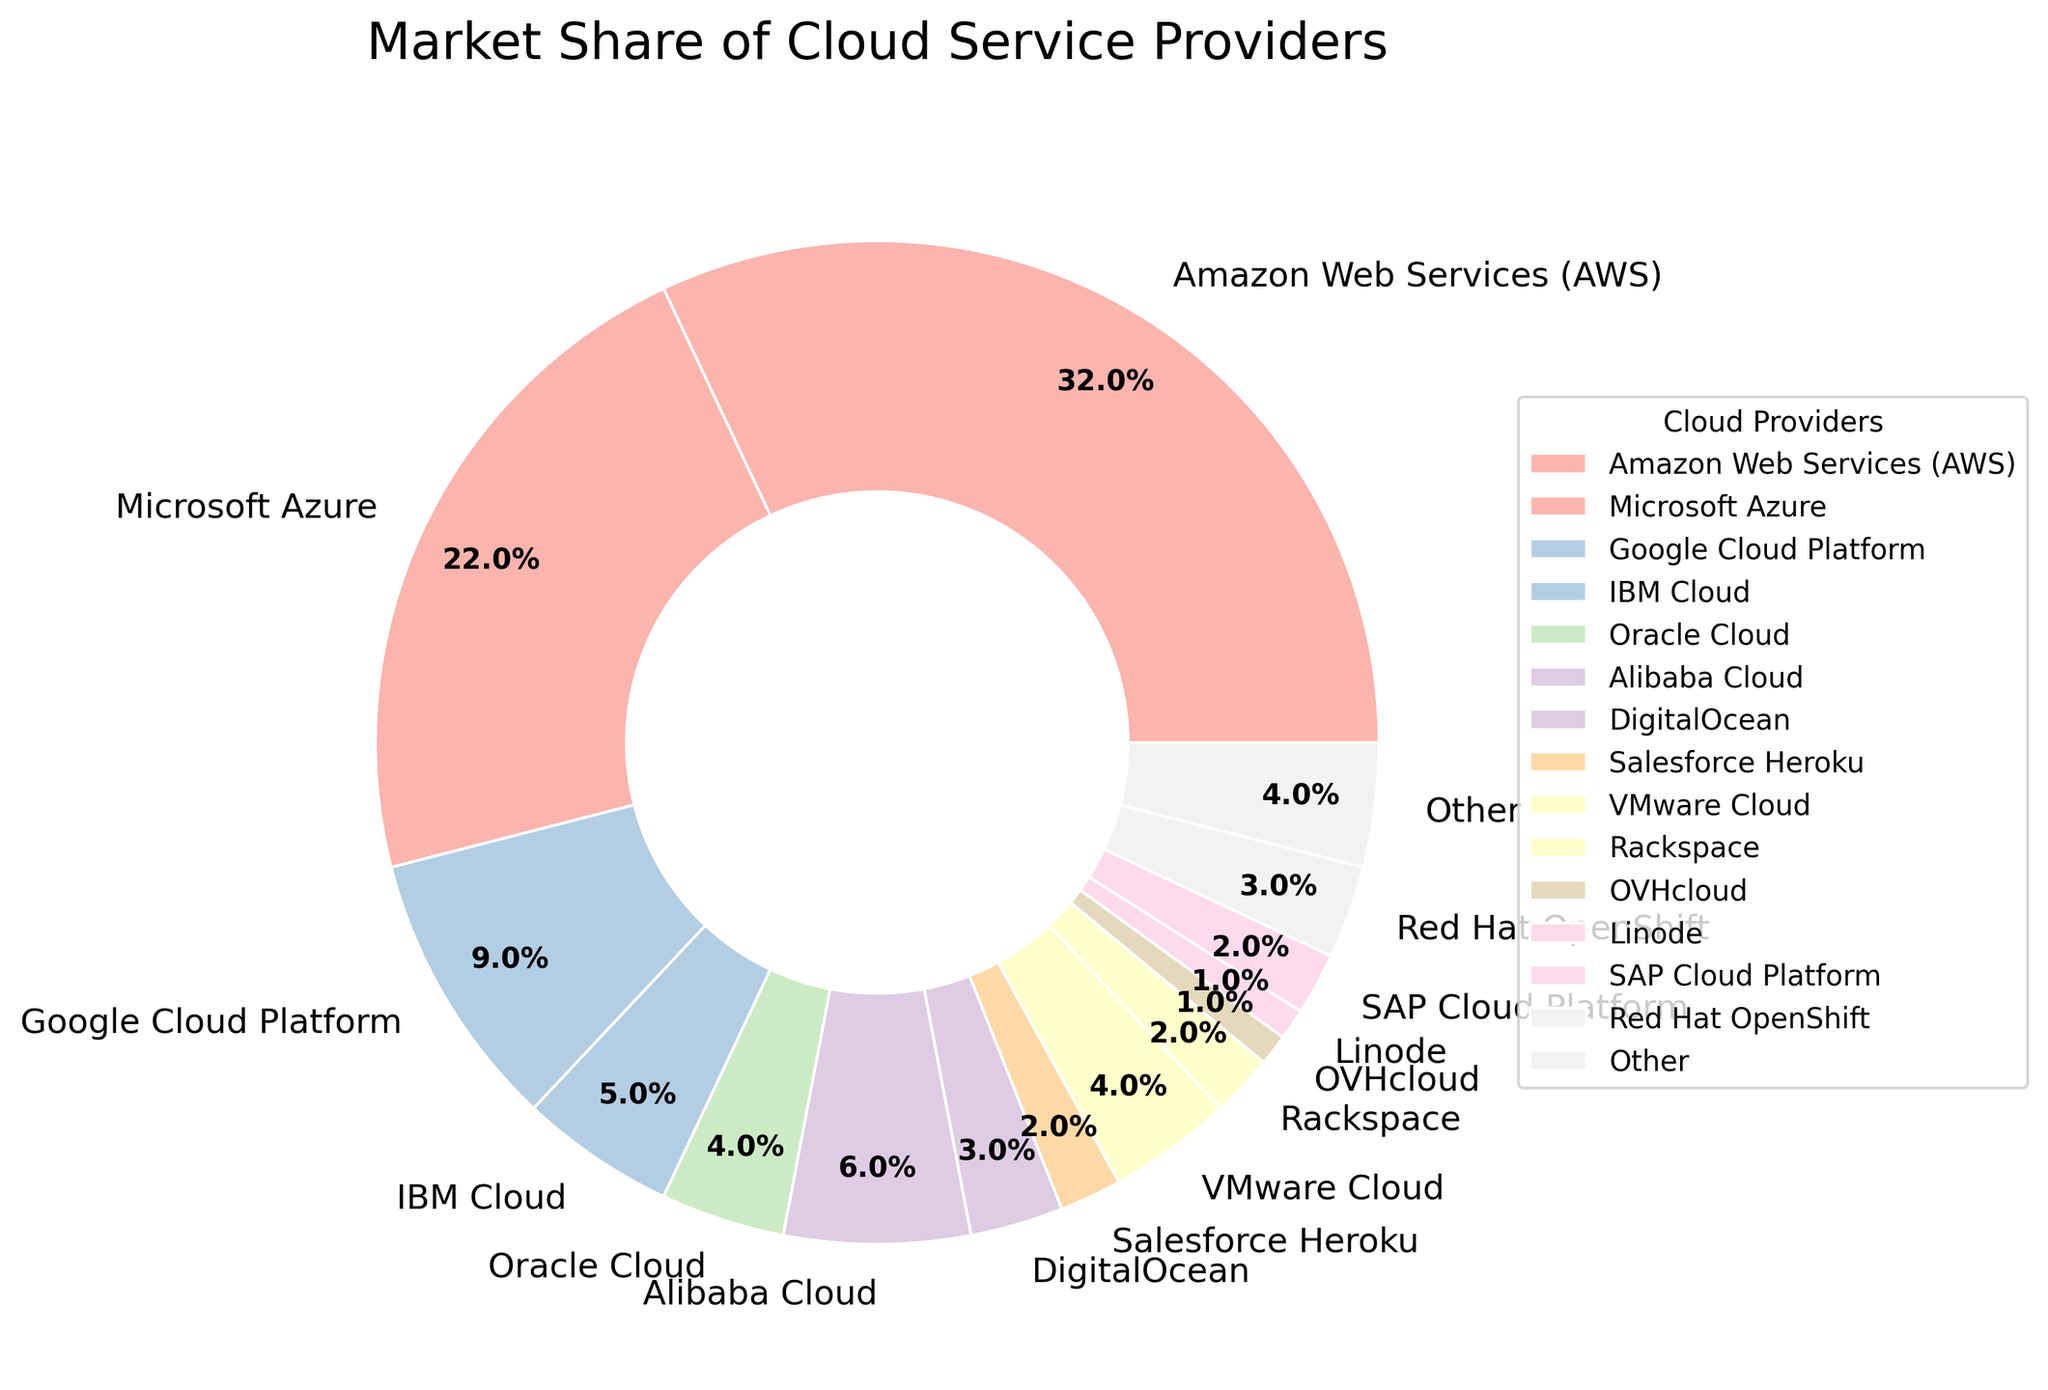What is the market share of Amazon Web Services (AWS)? AWS has a label indicating its market share. The label on the segment reads 32%.
Answer: 32% Which cloud provider holds the second-largest market share? By examining the segments, the second-largest share corresponds to Microsoft Azure, which is labeled as 22%.
Answer: Microsoft Azure What is the combined market share of IBM Cloud, Oracle Cloud, and VMware Cloud? Sum the market shares of IBM Cloud (5%), Oracle Cloud (4%), and VMware Cloud (4%): 5% + 4% + 4% = 13%.
Answer: 13% Is the market share of Alibaba Cloud greater than that of Google Cloud Platform? Alibaba Cloud's market share is 6%, while Google Cloud Platform's market share is 9%. Comparing these, 6% < 9%.
Answer: No What is the total market share of cloud providers with a market share of 2% each? Identify providers with 2% each: Salesforce Heroku, Rackspace, SAP Cloud Platform. Sum these shares: 2% + 2% + 2% = 6%.
Answer: 6% Which provider has the lowest market share, and what is it? Notice the segment with the smallest wedge and its label. OVHcloud and Linode both have a market share of 1%, sharing the lowest spot.
Answer: OVHcloud and Linode, 1% How does the market share of 'Other' compare to DigitalOcean? 'Other' has a market share of 4%, and DigitalOcean has 3%. Comparing these, 4% > 3%.
Answer: 'Other' is greater What is the cumulative market share of the three largest cloud providers? Sum the market shares of AWS (32%), Microsoft Azure (22%), and Google Cloud Platform (9%): 32% + 22% + 9% = 63%.
Answer: 63% How many cloud providers have a market share greater than or equal to 5%? From the pie chart, identify AWS (32%), Microsoft Azure (22%), Google Cloud Platform (9%), IBM Cloud (5%), and Alibaba Cloud (6%). Count them: 5 providers.
Answer: 5 What would be the difference in total market share if AWS and Microsoft Azure were merged? Combine AWS (32%) and Microsoft Azure (22%): 32% + 22% = 54%.
Answer: 54% 